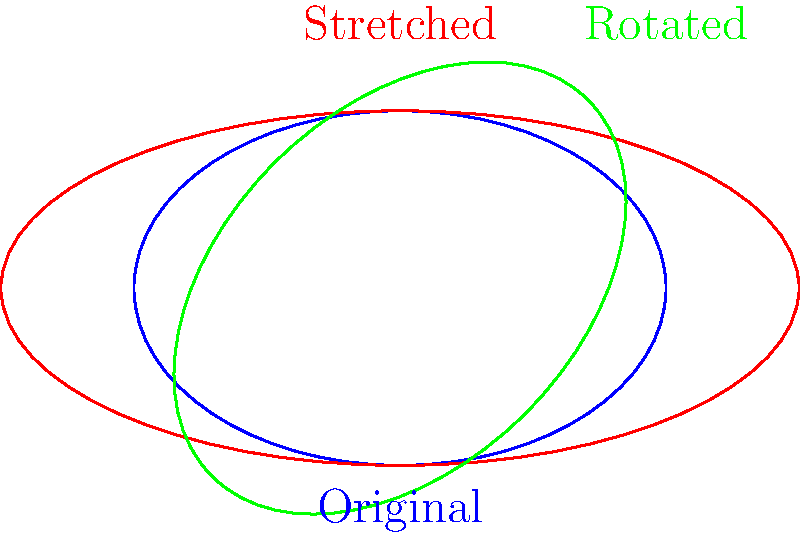As an athlete familiar with various playing fields, consider the topological properties of a sports field. If a circular running track is deformed into an ellipse or rotated, which of the following properties would remain unchanged?

a) Area
b) Perimeter
c) Number of holes
d) Angle between intersecting lines Let's analyze each option step-by-step:

1. Area: When a shape is deformed, stretched, or rotated, its area can change. For example, stretching a circle into an ellipse increases its area. Therefore, area is not preserved under topological transformations.

2. Perimeter: Similar to area, the perimeter of a shape can change when it's deformed or stretched. An ellipse has a different perimeter than a circle of the same radius. Thus, perimeter is not a topological invariant.

3. Number of holes: Topological transformations such as stretching, bending, or rotating do not create or eliminate holes in a shape. A circular track has one hole (the inside of the track), and this remains true for an elliptical or rotated track. The number of holes is a fundamental topological property that remains invariant under continuous deformations.

4. Angle between intersecting lines: Angles are not preserved under general topological transformations. Stretching or rotating a shape can alter the angles between lines on the surface. For instance, right angles on a circular track may not remain right angles when the track is deformed into an ellipse.

In topology, properties that remain unchanged under continuous deformations are called topological invariants. Of the options given, only the number of holes is a topological invariant.
Answer: Number of holes 